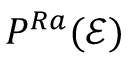<formula> <loc_0><loc_0><loc_500><loc_500>P ^ { R a } ( \mathcal { E } )</formula> 